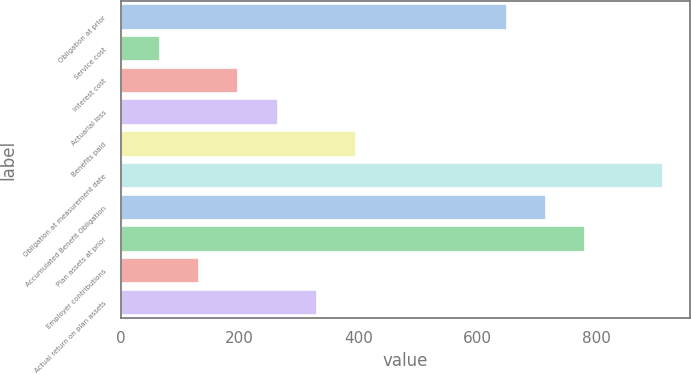Convert chart. <chart><loc_0><loc_0><loc_500><loc_500><bar_chart><fcel>Obligation at prior<fcel>Service cost<fcel>Interest cost<fcel>Actuarial loss<fcel>Benefits paid<fcel>Obligation at measurement date<fcel>Accumulated Benefit Obligation<fcel>Plan assets at prior<fcel>Employer contributions<fcel>Actual return on plan assets<nl><fcel>649<fcel>66.7<fcel>198.1<fcel>263.8<fcel>395.2<fcel>911.8<fcel>714.7<fcel>780.4<fcel>132.4<fcel>329.5<nl></chart> 